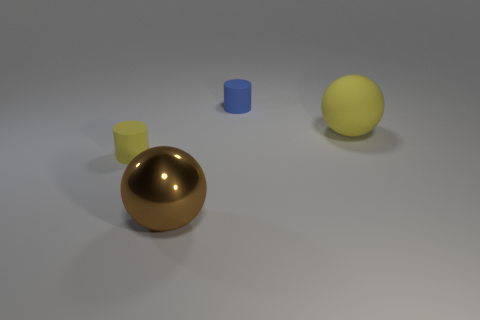Is there a yellow matte sphere that is to the left of the rubber cylinder behind the cylinder to the left of the large metallic sphere?
Keep it short and to the point. No. There is a cylinder that is on the right side of the yellow matte cylinder; is it the same size as the shiny thing?
Ensure brevity in your answer.  No. What number of yellow things are the same size as the brown sphere?
Give a very brief answer. 1. The other rubber object that is the same color as the big rubber object is what size?
Your answer should be compact. Small. Do the large metallic thing and the large matte thing have the same color?
Make the answer very short. No. There is a tiny yellow rubber thing; what shape is it?
Your answer should be compact. Cylinder. Is there a large metallic ball of the same color as the large rubber object?
Provide a short and direct response. No. Is the number of small blue rubber cylinders that are behind the large metal thing greater than the number of big shiny objects?
Make the answer very short. No. There is a tiny yellow object; is it the same shape as the tiny rubber thing behind the yellow cylinder?
Ensure brevity in your answer.  Yes. Are any small cylinders visible?
Provide a short and direct response. Yes. 